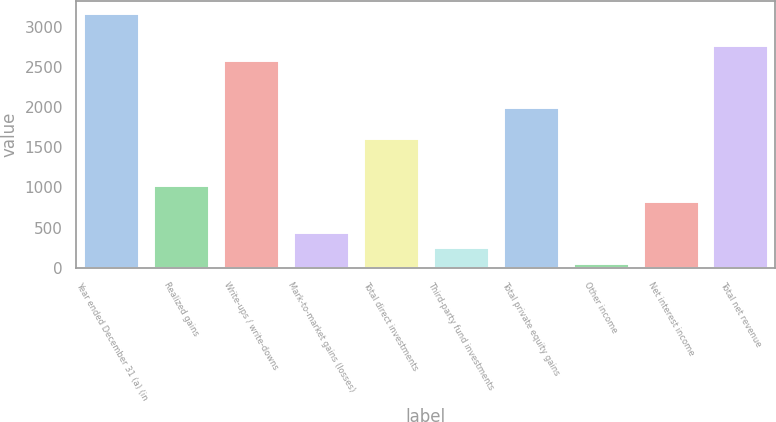Convert chart. <chart><loc_0><loc_0><loc_500><loc_500><bar_chart><fcel>Year ended December 31 (a) (in<fcel>Realized gains<fcel>Write-ups / write-downs<fcel>Mark-to-market gains (losses)<fcel>Total direct investments<fcel>Third-party fund investments<fcel>Total private equity gains<fcel>Other income<fcel>Net interest income<fcel>Total net revenue<nl><fcel>3167.8<fcel>1030.5<fcel>2584.9<fcel>447.6<fcel>1613.4<fcel>253.3<fcel>2002<fcel>59<fcel>836.2<fcel>2779.2<nl></chart> 